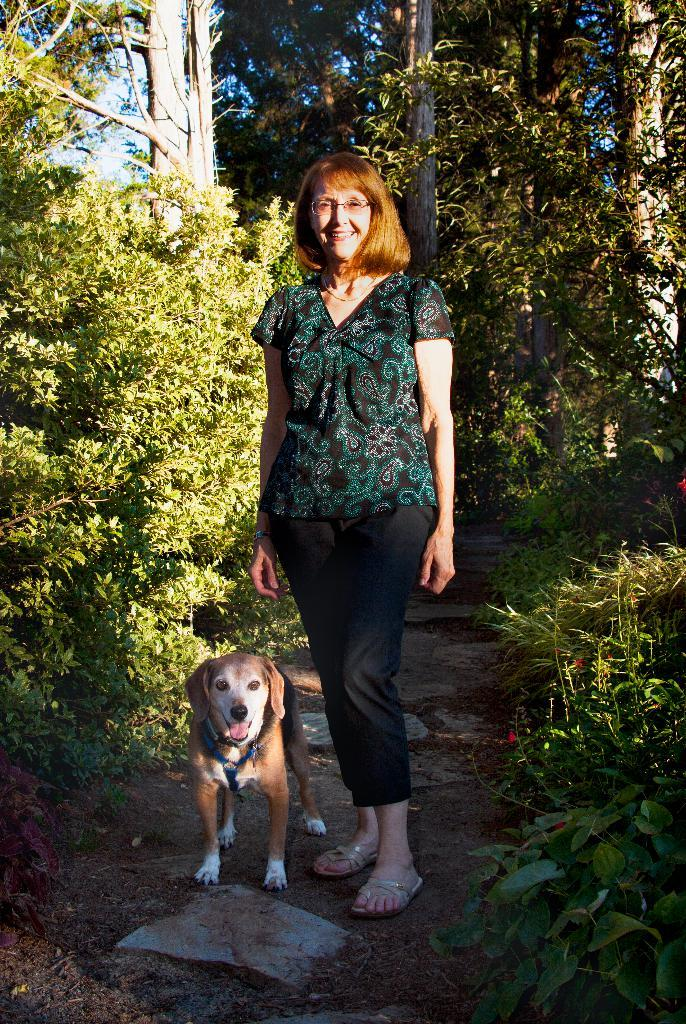Who is the main subject in the image? There is a lady in the image. What is the lady wearing? The lady is wearing spectacles. What is the lady's posture in the image? The lady is standing. What other living creature is present in the image? There is a dog in the image. What type of surface is visible in the image? The ground is visible in the image. What type of vegetation can be seen in the image? There are plants and trees in the image. What part of the natural environment is visible in the image? The sky is visible in the image. How many teeth can be seen in the image? There are no teeth visible in the image; it features a lady, a dog, and various plants and trees. What type of farm animals can be seen in the image? There are no farm animals present in the image. 